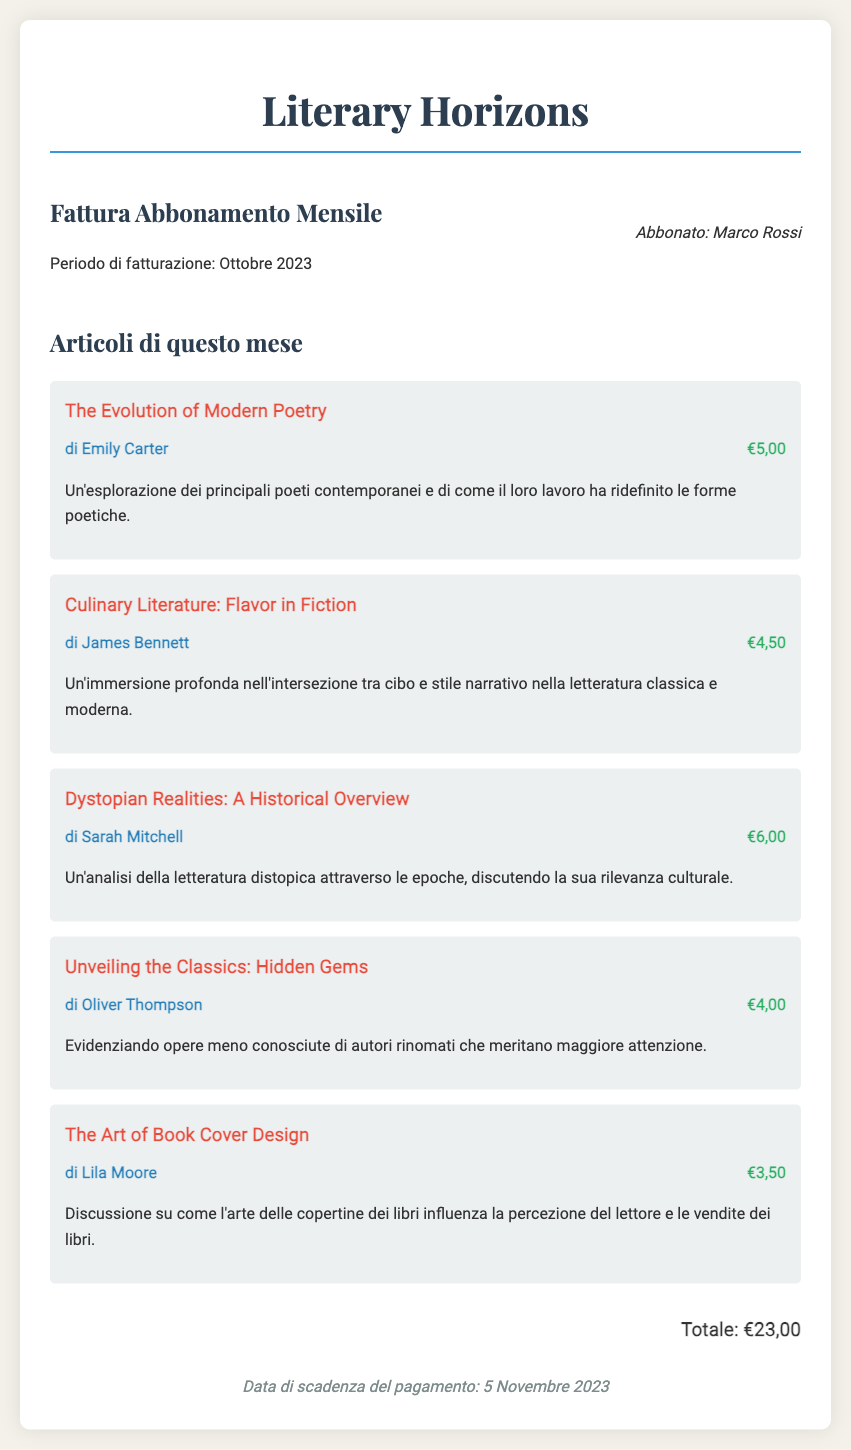What is the name of the subscriber? The subscriber is mentioned at the top of the bill as "Marco Rossi".
Answer: Marco Rossi What is the total amount due? The total amount due is specified at the bottom of the document as "€23,00".
Answer: €23,00 How many articles are listed in this month's bill? The document lists five different articles under the "Articoli di questo mese" section.
Answer: 5 Who wrote the article "Culinary Literature: Flavor in Fiction"? The author of the mentioned article is "James Bennett".
Answer: James Bennett What is the due date for payment? The due date for payment is indicated as "5 Novembre 2023".
Answer: 5 Novembre 2023 Which article has the highest price? The article with the highest price, "Dystopian Realities: A Historical Overview", is listed at "€6,00".
Answer: €6,00 What genre does the article "The Evolution of Modern Poetry" explore? This article explores the genre of contemporary poetry.
Answer: Contemporary poetry What is the total price of the articles by Lila Moore and Oliver Thompson? The total price is calculated by adding €3,50 (Lila Moore) and €4,00 (Oliver Thompson) which equals €7,50.
Answer: €7,50 What section does the article "Unveiling the Classics: Hidden Gems" belong to? The article is part of the "Articoli di questo mese" section.
Answer: Articoli di questo mese 